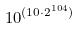<formula> <loc_0><loc_0><loc_500><loc_500>1 0 ^ { ( 1 0 \cdot 2 ^ { 1 0 4 } ) }</formula> 